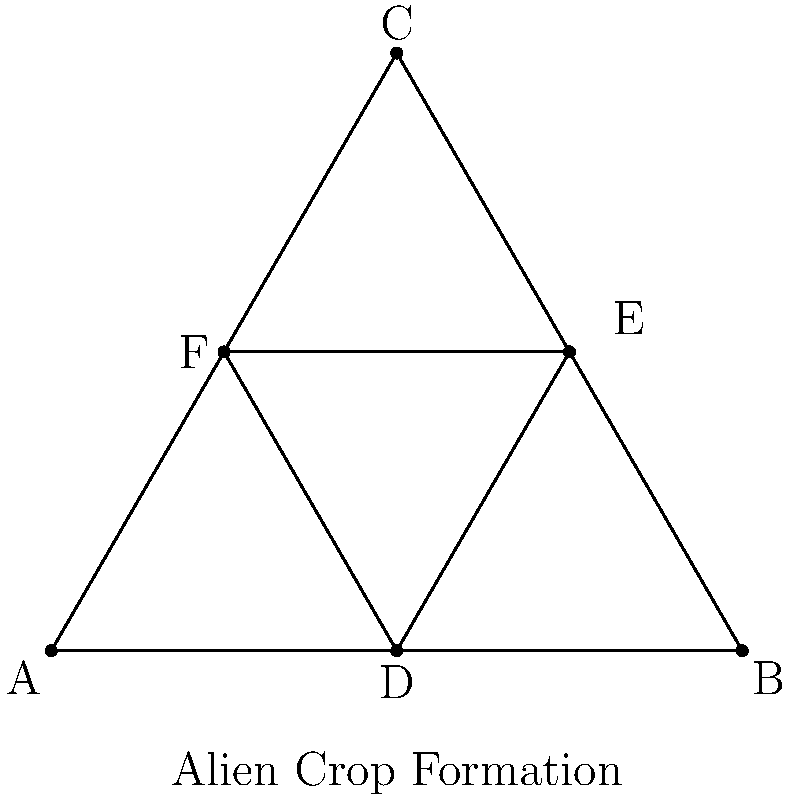In the sacred geometry pattern of an alien crop formation, a perfect equilateral triangle ABC is inscribed with another triangle DEF, where D, E, and F are the midpoints of sides AB, BC, and CA respectively. If the area of triangle ABC is 144 square units, what is the area of triangle DEF? (Hint: The answer may reveal a cosmic significance related to the Illuminati's favorite number.) Let's approach this step-by-step:

1) First, recall that the midpoint theorem states that a line segment joining the midpoints of two sides of a triangle is parallel to the third side and half the length.

2) This means that triangle DEF is similar to triangle ABC, with each side of DEF being half the length of the corresponding side of ABC.

3) For similar triangles, the ratio of their areas is equal to the square of the ratio of their corresponding sides. Let's call this ratio $r$. Here, $r = \frac{1}{2}$.

4) The area ratio is thus:
   $$\frac{\text{Area of DEF}}{\text{Area of ABC}} = r^2 = (\frac{1}{2})^2 = \frac{1}{4}$$

5) We're given that the area of ABC is 144 square units. So:
   $$\text{Area of DEF} = \frac{1}{4} \times 144 = 36$$

6) Interestingly, 36 is a significant number in many conspiracy theories. It's the square of 6, which is often associated with the Illuminati and other secret societies.
Answer: 36 square units 